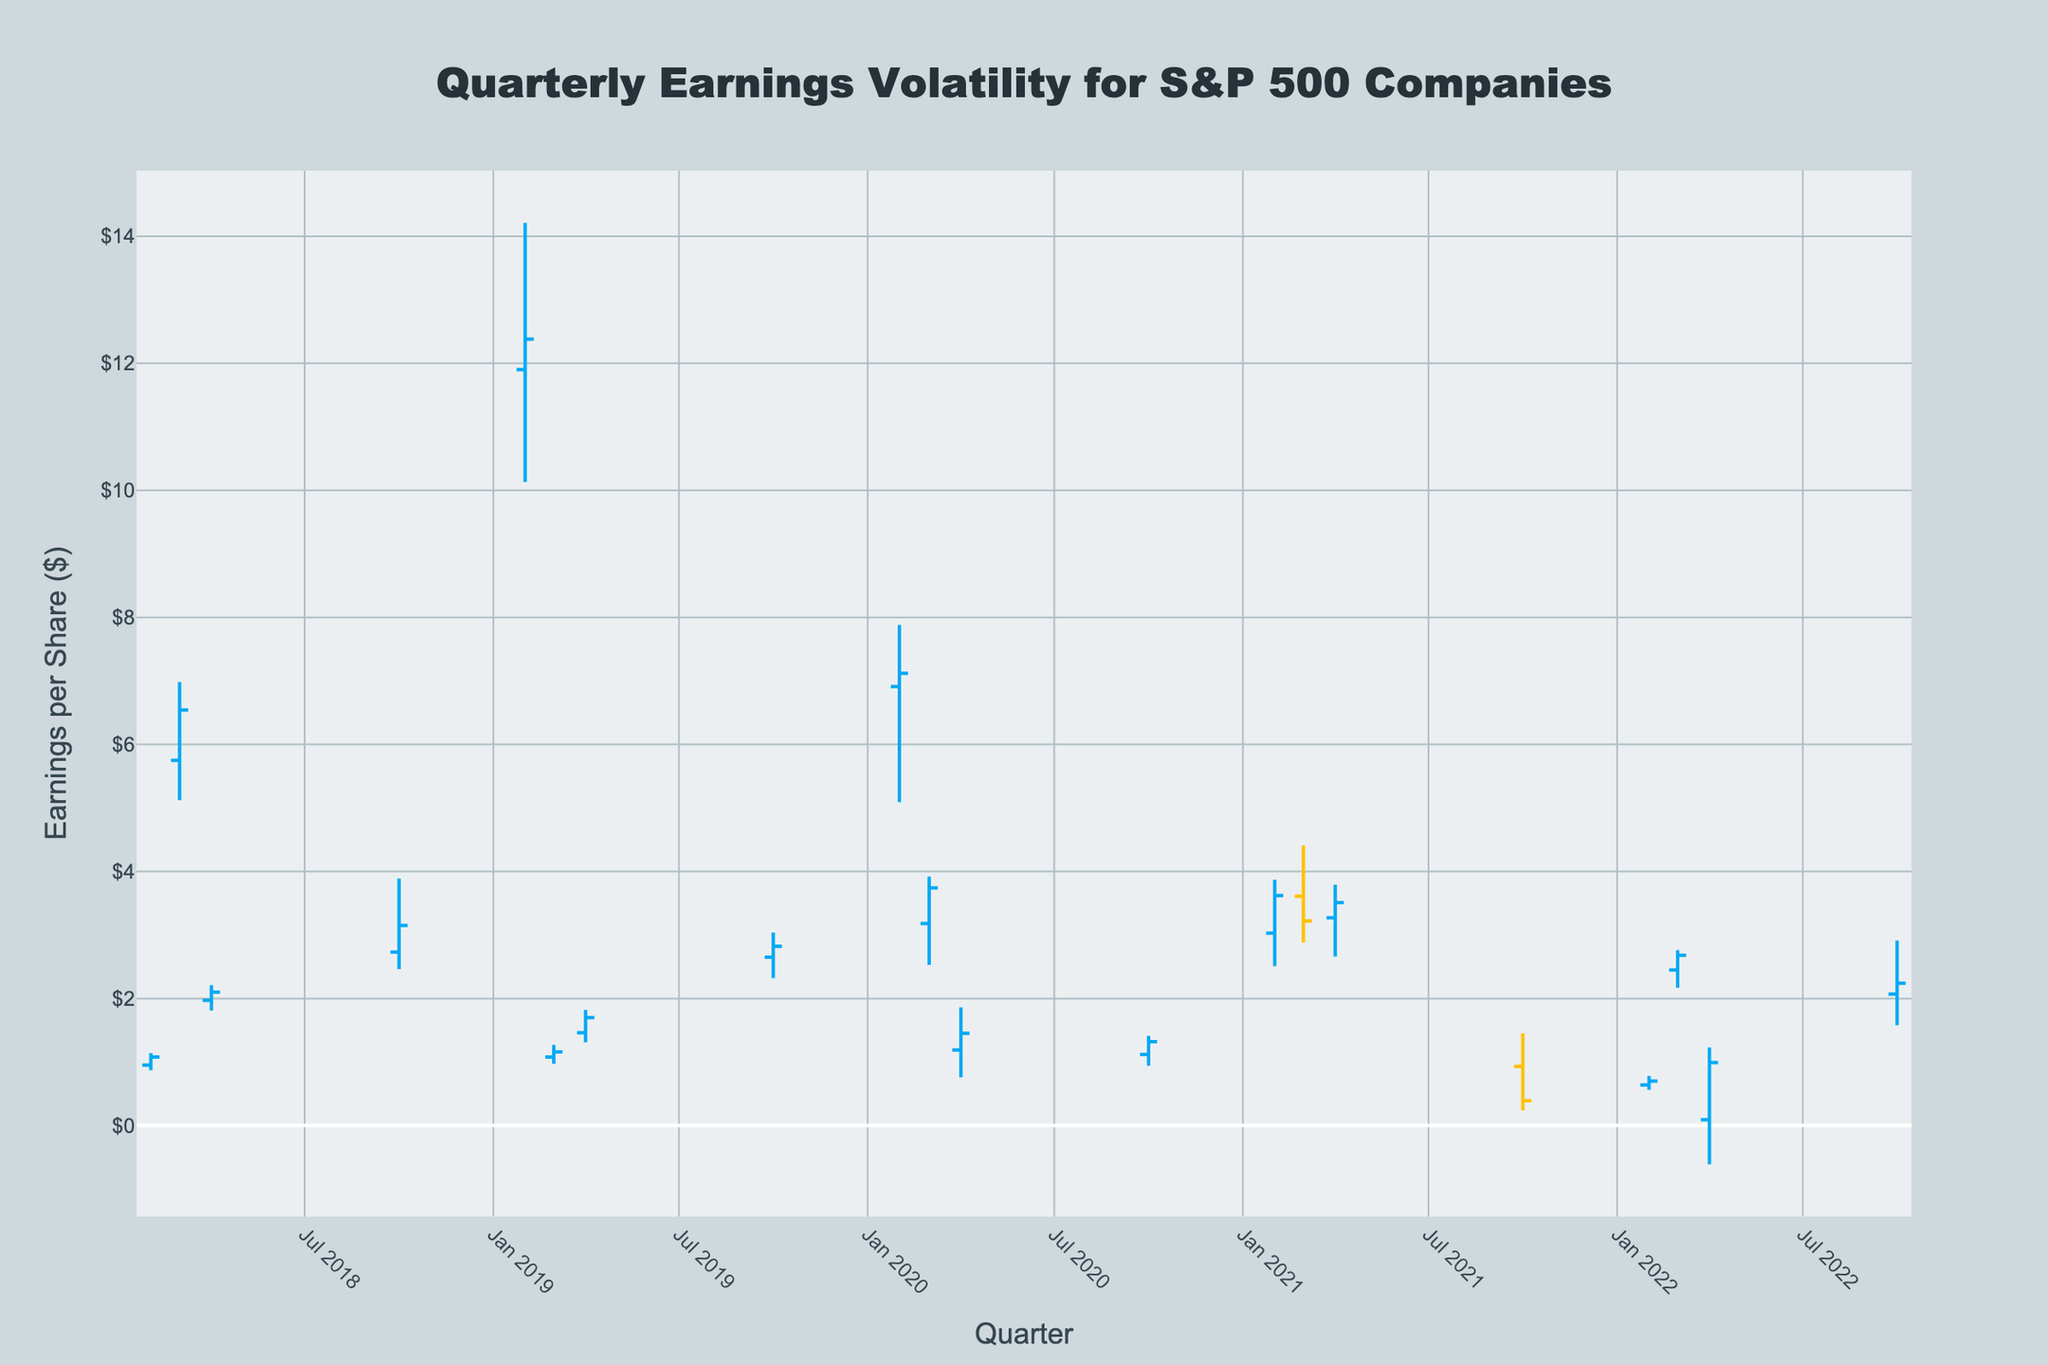What's the title of the figure? The title of the figure is displayed prominently at the top of the chart.
Answer: Quarterly Earnings Volatility for S&P 500 Companies How many data points (quarters) are displayed on the chart? By counting the unique quarters displayed on the x-axis or the bars in the chart, we can determine the number of data points.
Answer: 20 Which company showed the highest earnings in a single quarter? By examining the highest visible "High" value on the y-axis and matching it with the corresponding company and quarter, we can identify the company with the highest earnings.
Answer: Alphabet Inc. in 2019Q2 What is the trend in Apple's earnings from the first to the last quarter shown? To identify the trend, observe the opening and closing values for Apple Inc. across the quarters 2018Q1 to 2022Q4.
Answer: Mixed, with fluctuations up and down Compare the earnings volatility of Amazon.com Inc. and Tesla Inc. Identify the "High", "Low", and "Close" values across their respective quarters and calculate the range (High - Low) for each.
Answer: Amazon.com Inc. has higher volatility compared to Tesla Inc Which company had an earnings drop from opening to closing in the corresponding quarter? Look for bars where the closing value is lower than the opening value, indicated by a bar that is visually downward sloping.
Answer: Tesla Inc. in 2021Q1 What is the average closing value for Microsoft Corporation over the quarters displayed? Calculate the average by summing the closing values for Microsoft Corporation and dividing by the number of quarters with data for them.
Answer: 1.08 (as there is only one quarter of data for Microsoft) Which company had the smallest difference between the highest and lowest earnings in any single quarter? Calculate the difference (High - Low) for each company and identify the smallest value.
Answer: Coca-Cola Company in 2022Q2 Was there any company with negative earnings in any quarter? Check for "Low" values that dip below 0 on the y-axis, indicating negative earnings.
Answer: Disney in 2022Q4 Which company had the highest closing value in 2020? Compare the closing values for each company in the quarters of 2020 and identify the highest one.
Answer: UnitedHealth Group Inc. in 2020Q2 